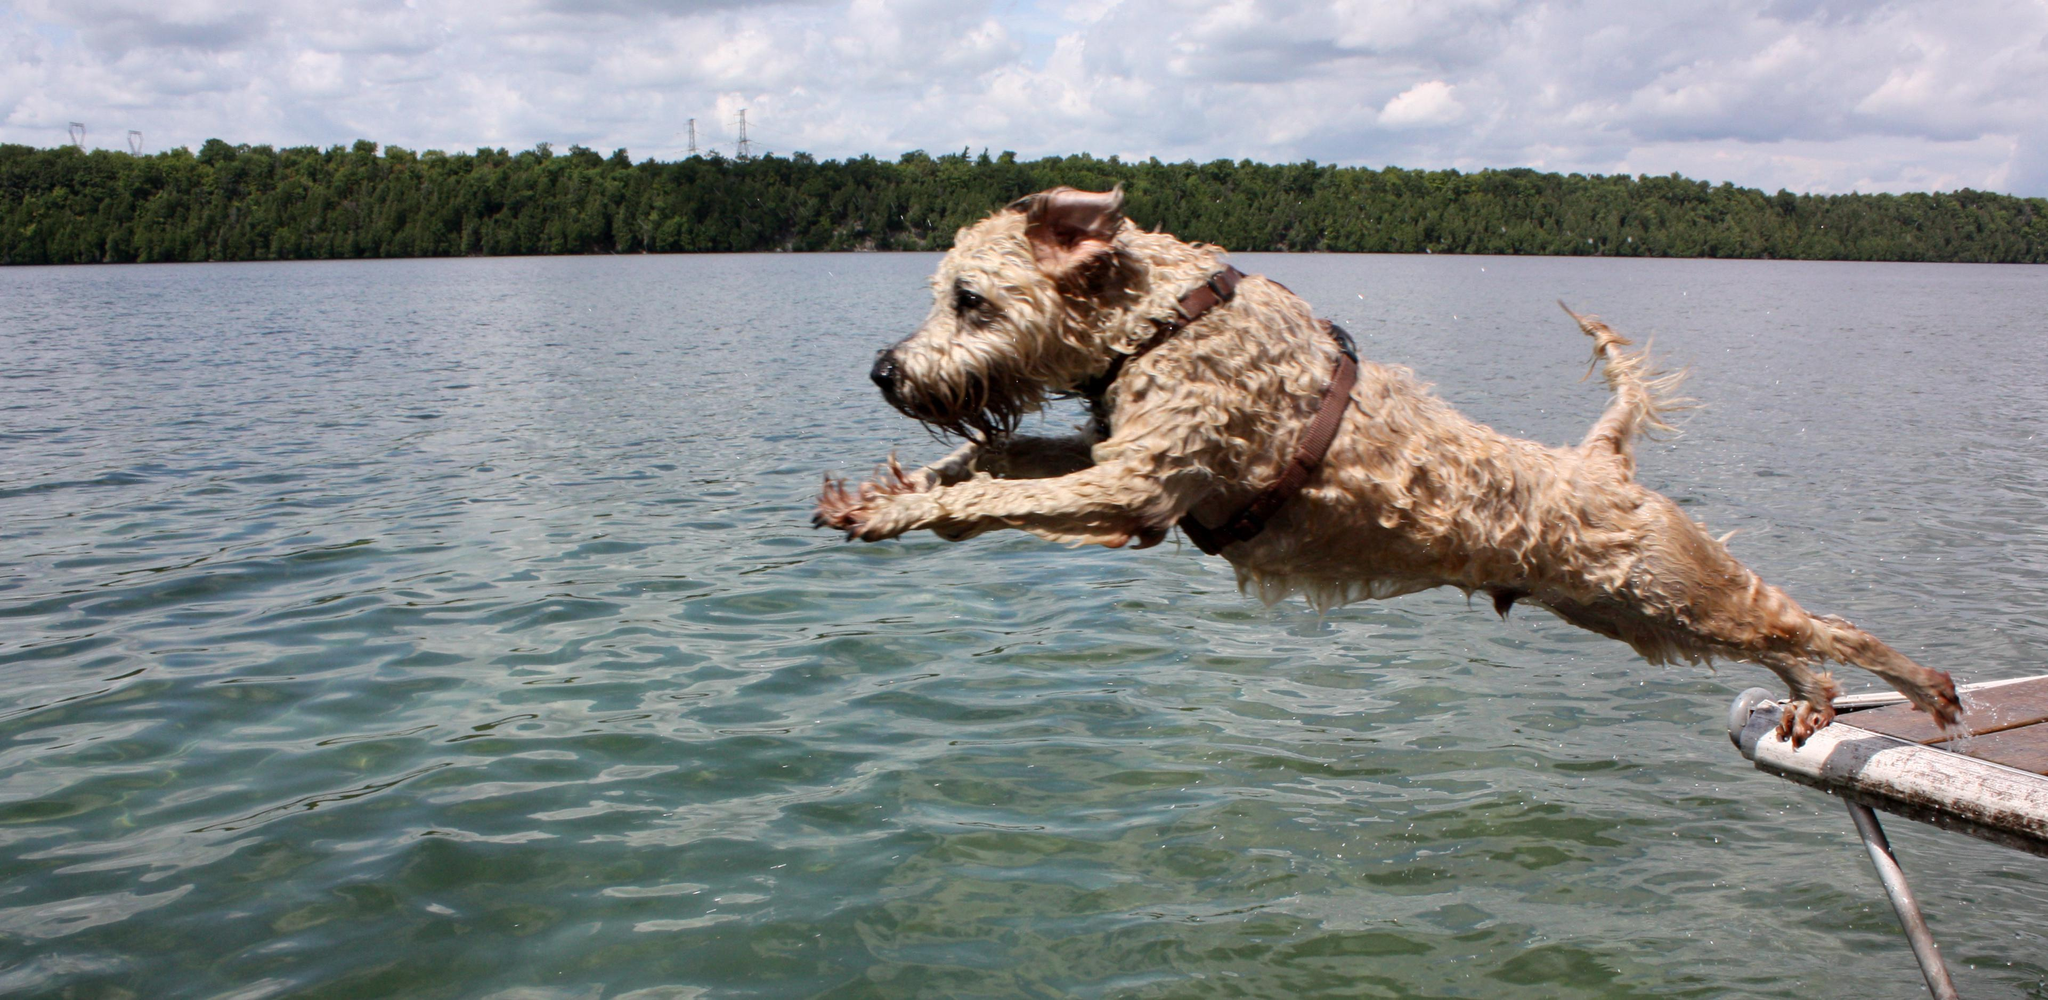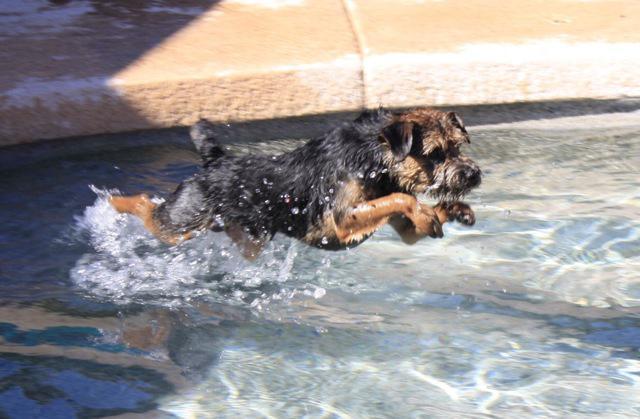The first image is the image on the left, the second image is the image on the right. Considering the images on both sides, is "dogs are leaping in the water" valid? Answer yes or no. Yes. The first image is the image on the left, the second image is the image on the right. Examine the images to the left and right. Is the description "Each image contains a wet dog in mid stride over water." accurate? Answer yes or no. Yes. 